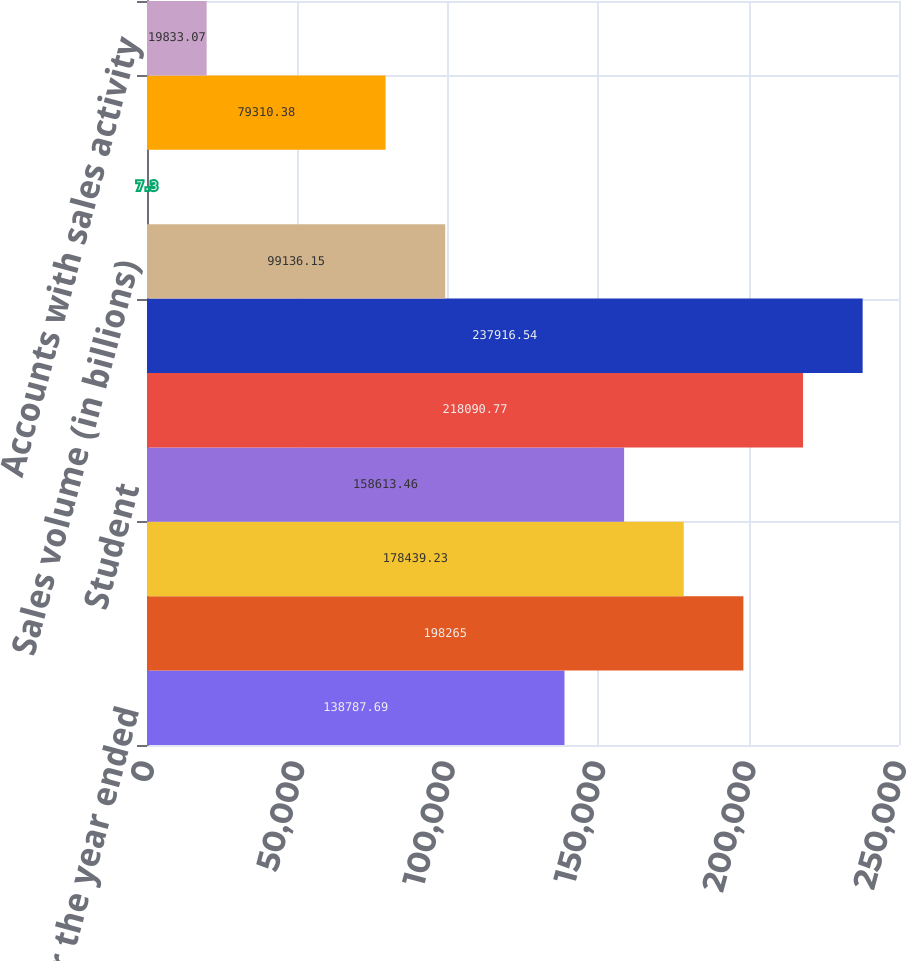<chart> <loc_0><loc_0><loc_500><loc_500><bar_chart><fcel>As of or for the year ended<fcel>Credit Card<fcel>Auto<fcel>Student<fcel>Total loans<fcel>Total assets<fcel>Sales volume (in billions)<fcel>New accounts opened<fcel>Open accounts<fcel>Accounts with sales activity<nl><fcel>138788<fcel>198265<fcel>178439<fcel>158613<fcel>218091<fcel>237917<fcel>99136.1<fcel>7.3<fcel>79310.4<fcel>19833.1<nl></chart> 